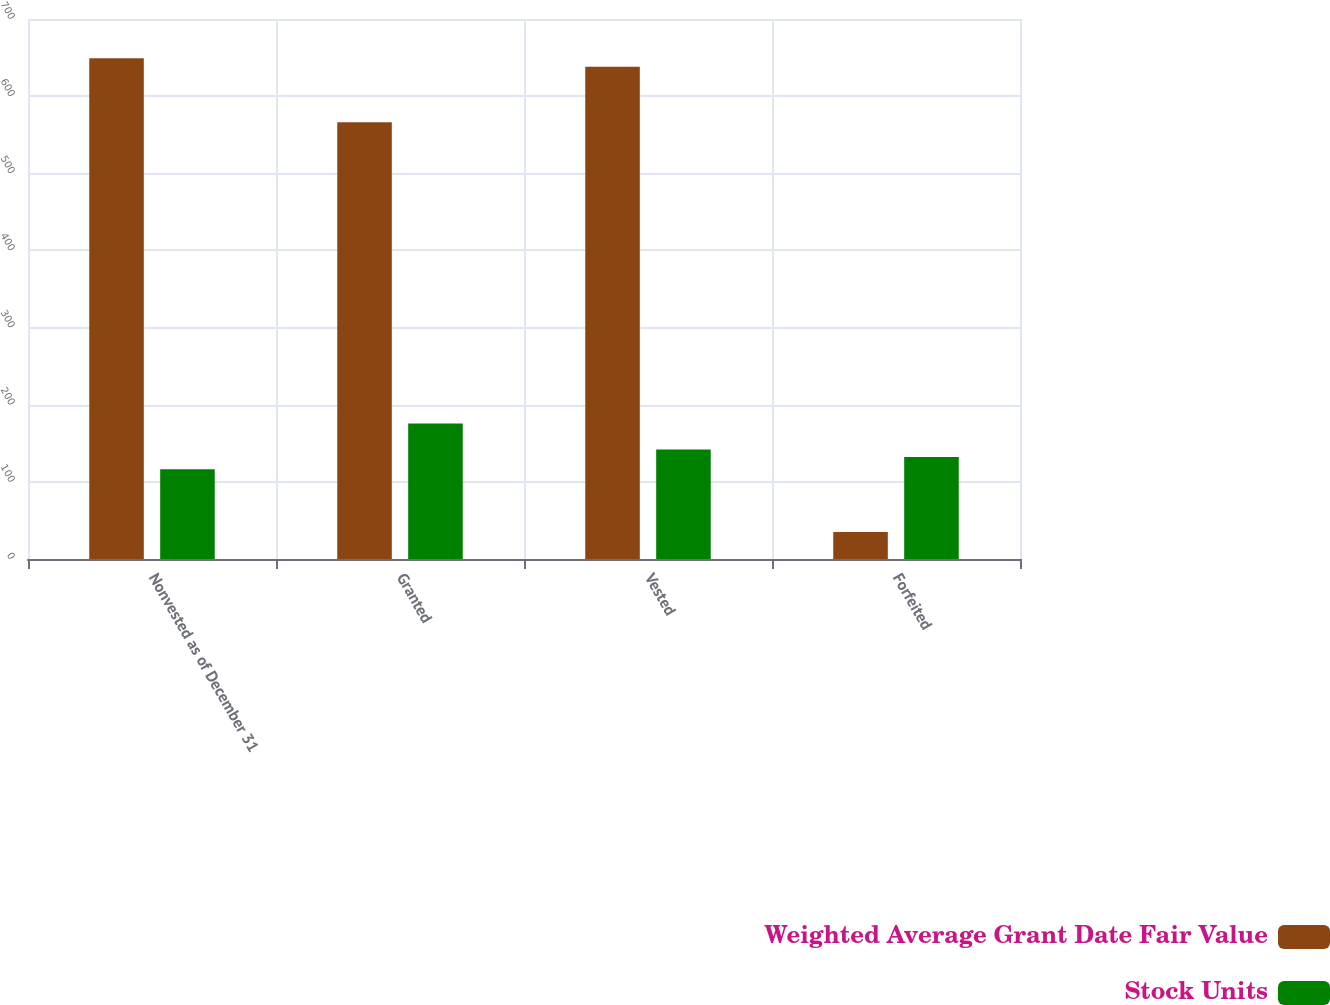<chart> <loc_0><loc_0><loc_500><loc_500><stacked_bar_chart><ecel><fcel>Nonvested as of December 31<fcel>Granted<fcel>Vested<fcel>Forfeited<nl><fcel>Weighted Average Grant Date Fair Value<fcel>649<fcel>566<fcel>638<fcel>35<nl><fcel>Stock Units<fcel>116.26<fcel>175.79<fcel>141.89<fcel>132.14<nl></chart> 